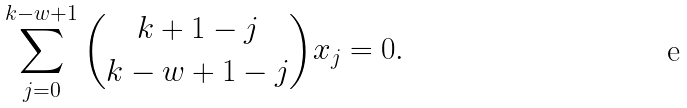Convert formula to latex. <formula><loc_0><loc_0><loc_500><loc_500>\sum _ { j = 0 } ^ { k - w + 1 } { k + 1 - j \choose k - w + 1 - j } x _ { j } = 0 .</formula> 